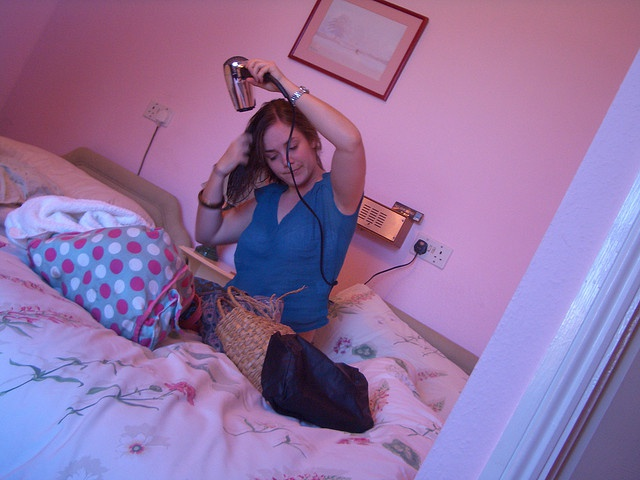Describe the objects in this image and their specific colors. I can see bed in purple, violet, and gray tones, people in purple, navy, brown, and black tones, handbag in purple, gray, blue, and lightblue tones, handbag in purple, black, navy, and blue tones, and hair drier in purple, brown, and black tones in this image. 